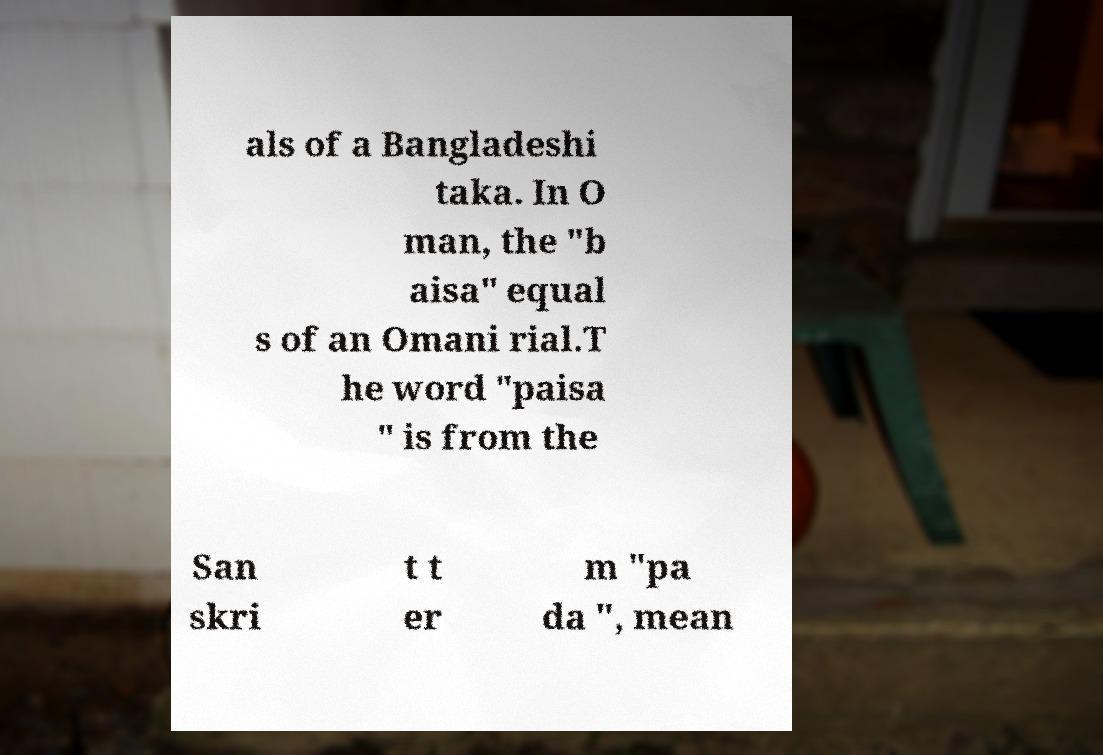There's text embedded in this image that I need extracted. Can you transcribe it verbatim? als of a Bangladeshi taka. In O man, the "b aisa" equal s of an Omani rial.T he word "paisa " is from the San skri t t er m "pa da ", mean 